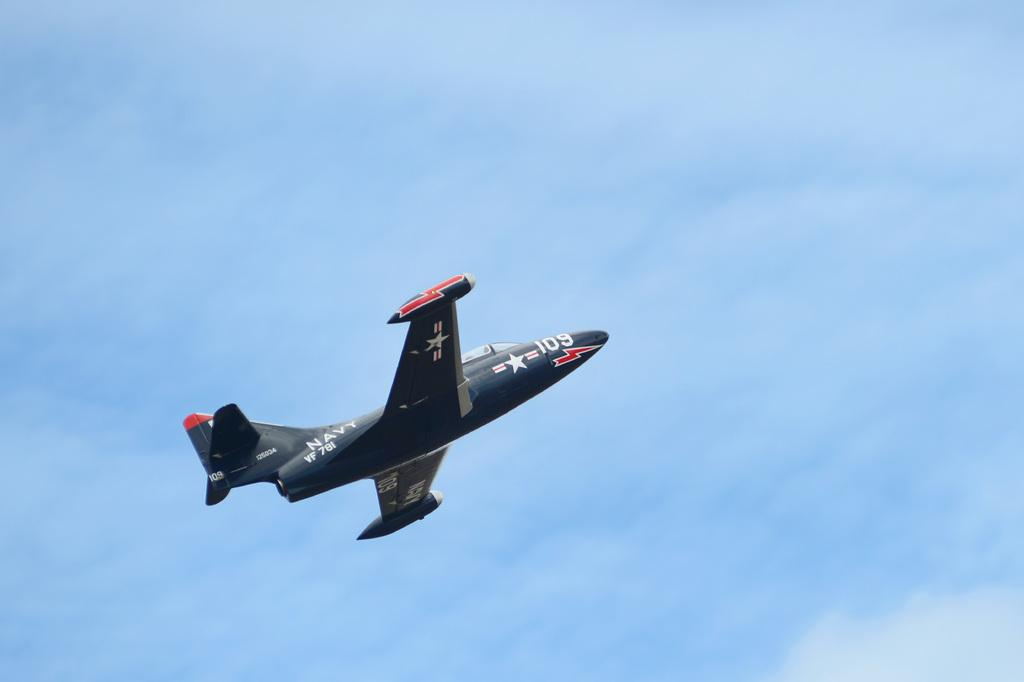What type of aircraft is in the image? There is a navy aircraft in the image. What is the aircraft doing in the image? The aircraft is flying in the sky. What type of shoes is the aircraft wearing in the image? Aircraft do not wear shoes, as they are inanimate objects. 